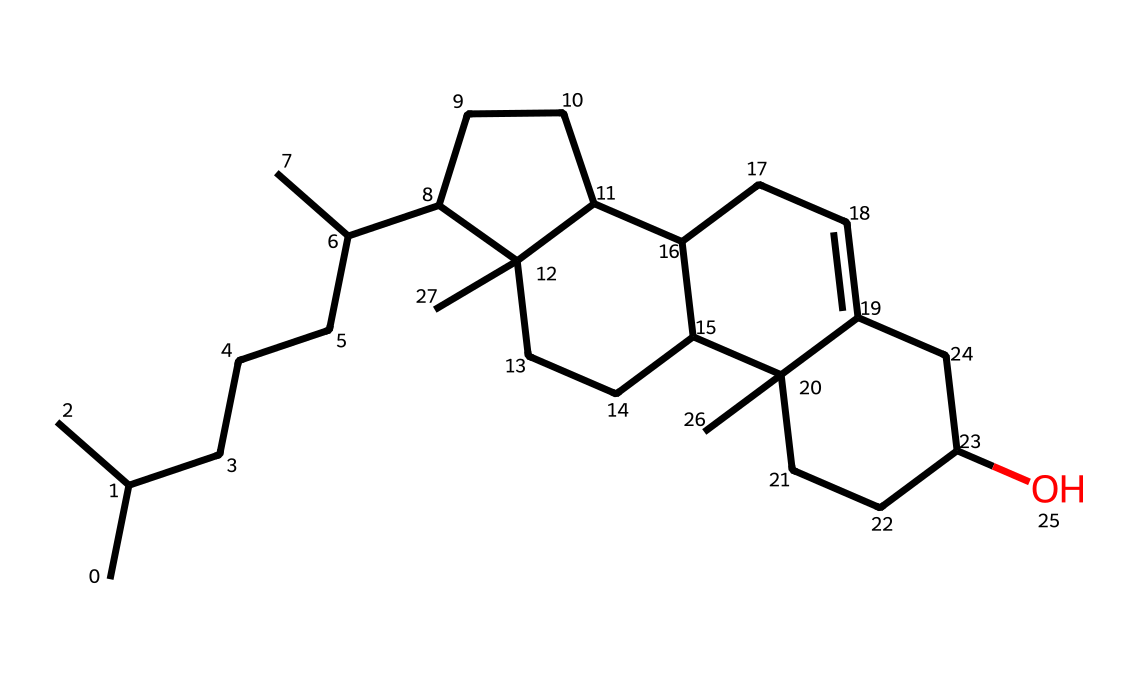What is the main functional group present in lanolin? The structure does not show a specific functional group like a carboxylic acid or alcohol prominently standing out, but it contains hydroxyl groups implied in the structure, indicating it is a fatty alcohol.
Answer: fatty alcohol How many carbons are present in the lanolin molecule? Counting the carbon atoms visible in the structure or deduced from the SMILES representation, the total number of carbon atoms is determined to be 30.
Answer: 30 What type of lipid class does lanolin belong to? Lanolin is categorized as a wax because of its long-chain fatty acid and alcohol components, which are indicative of waxy substances in lipids.
Answer: wax How many rings are present in the lanolin structure? From the structure, there are three distinct cycloalkane rings identified, confirming the presence of ring structures in the lanolin molecule.
Answer: 3 What is the estimated molecular weight of lanolin based on the structure? Based on the SMILES representation, calculating the molecular weight involves summing the atomic weights of all its 30 carbon, 56 hydrogen, and 1 oxygen atoms, resulting in an estimated molecular weight of about 442 g/mol.
Answer: 442 